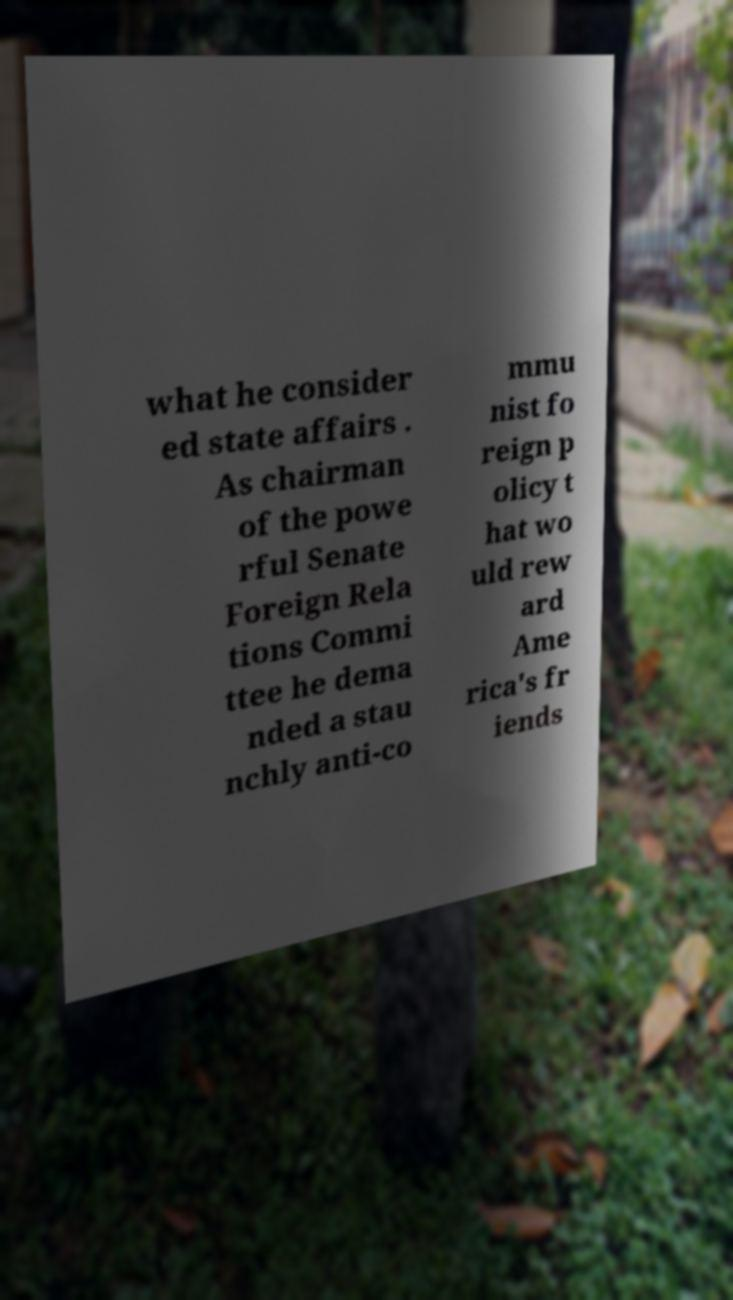Please read and relay the text visible in this image. What does it say? what he consider ed state affairs . As chairman of the powe rful Senate Foreign Rela tions Commi ttee he dema nded a stau nchly anti-co mmu nist fo reign p olicy t hat wo uld rew ard Ame rica's fr iends 